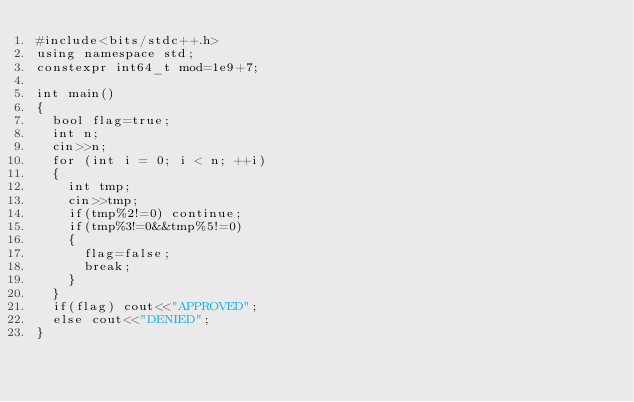<code> <loc_0><loc_0><loc_500><loc_500><_C++_>#include<bits/stdc++.h>
using namespace std;
constexpr int64_t mod=1e9+7;

int main()
{
  bool flag=true;
  int n;
  cin>>n;
  for (int i = 0; i < n; ++i)
  {
    int tmp;
    cin>>tmp;
    if(tmp%2!=0) continue;
    if(tmp%3!=0&&tmp%5!=0)
    {
      flag=false;
      break;
    }
  }
  if(flag) cout<<"APPROVED";
  else cout<<"DENIED";
}</code> 